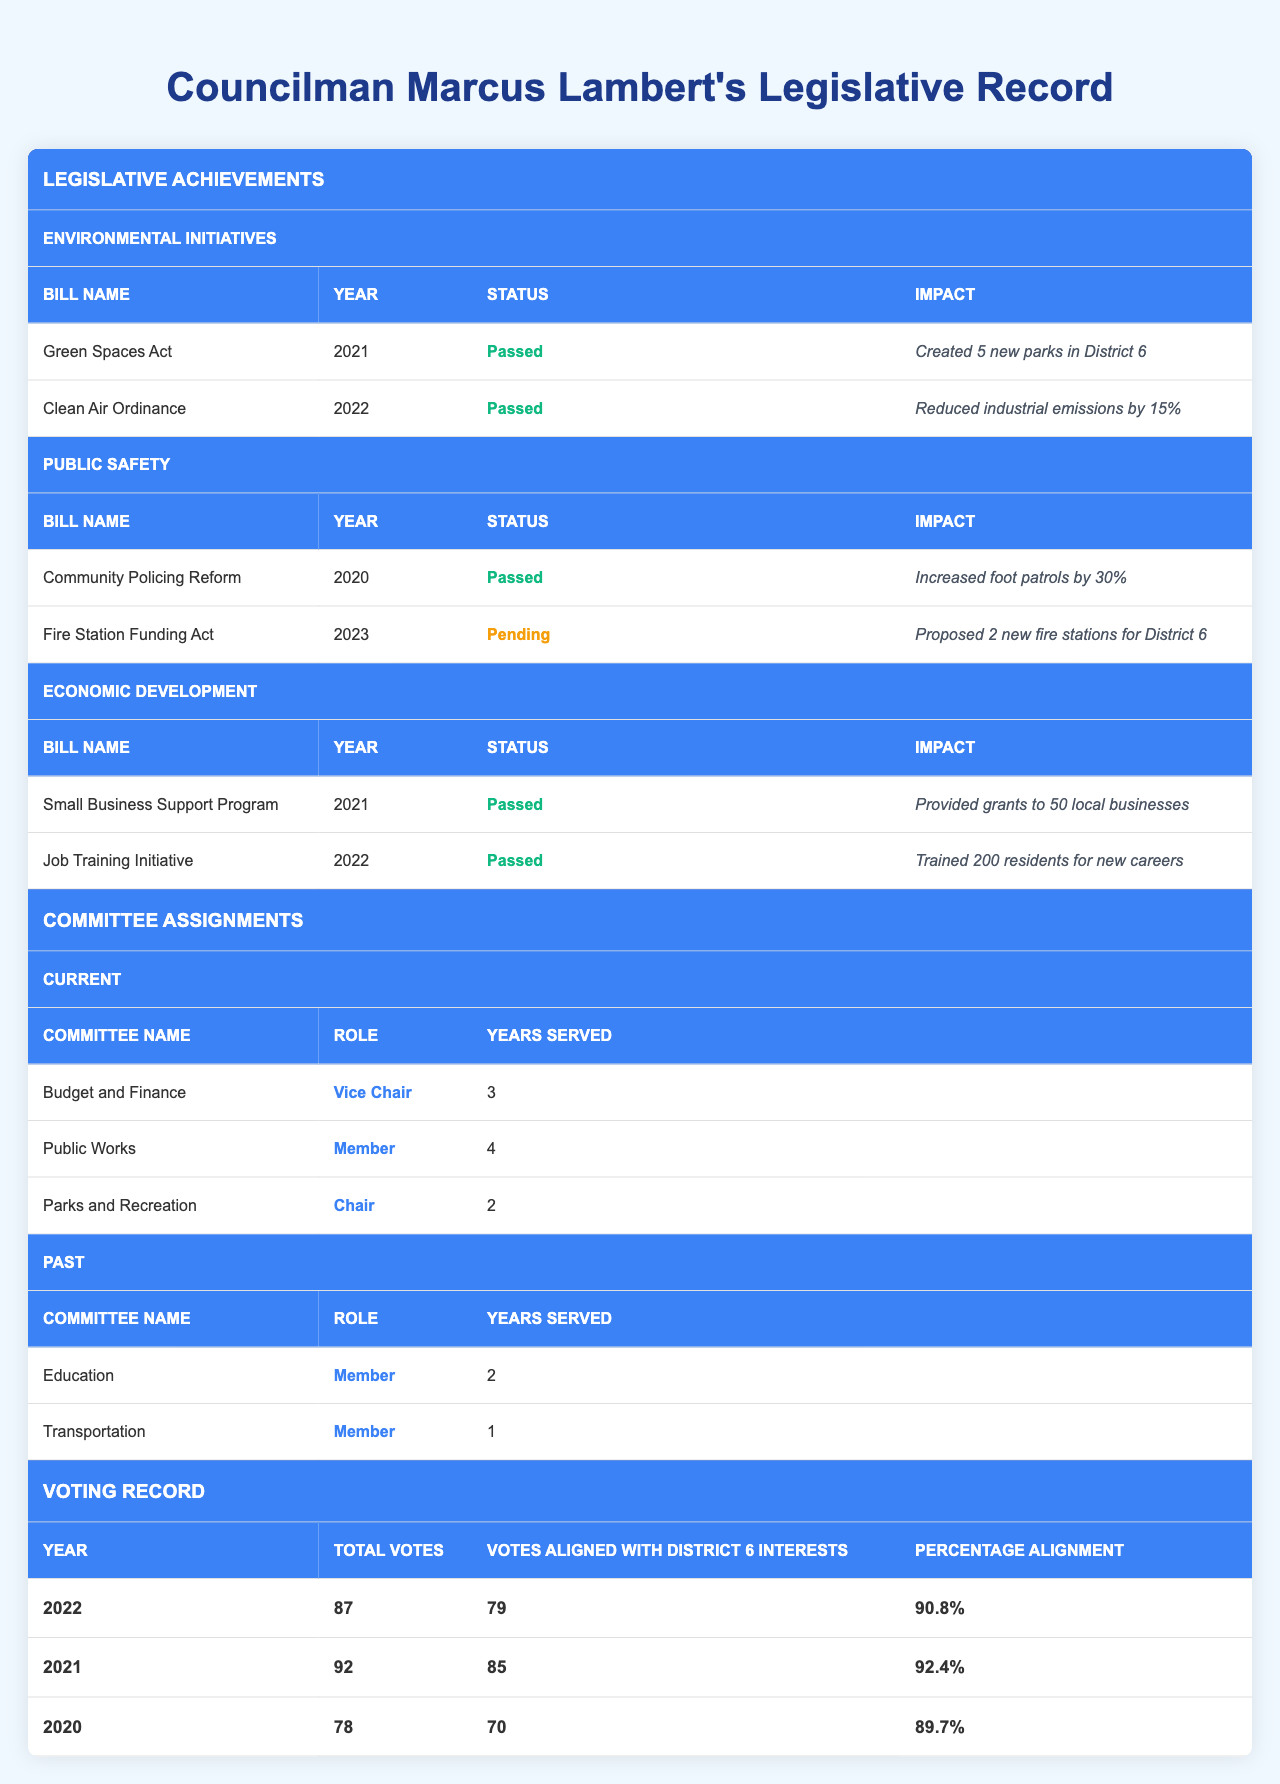What environmental initiative passed in 2021? The "Green Spaces Act" is listed under Environmental Initiatives with the year 2021 and the status "Passed".
Answer: Green Spaces Act How many years has Councilman Lambert served in the Public Works committee? The "Public Works" committee shows that Councilman Lambert has served for 4 years, as indicated in the Current Committee Assignments.
Answer: 4 years What was the impact of the "Clean Air Ordinance"? The impact statement for the "Clean Air Ordinance" specifies that it "Reduced industrial emissions by 15%", as shown in the Environmental Initiatives section.
Answer: Reduced industrial emissions by 15% Did Councilman Lambert's voting alignment exceed 90% in 2022? The percentage alignment for 2022 is noted as "90.8%", which is indeed above 90%.
Answer: Yes How many total votes did Councilman Lambert have in 2021? The table indicates the total votes for 2021 as 92, found in the Voting Record section.
Answer: 92 Which committee role has Councilman Lambert held the longest? By comparing the years served, "Public Works" (4 years) has the longest tenure, as it is shown in the Current Committee Assignments.
Answer: Public Works What percentage of Councilman Lambert's votes aligned with District 6 interests in 2020? The record shows that in 2020, the percentage alignment was "89.7%", found in the Voting Record section.
Answer: 89.7% In what year was the "Fire Station Funding Act" proposed, and what is its status? The "Fire Station Funding Act" is listed under Public Safety initiatives for the year 2023 and its status is "Pending".
Answer: Proposed in 2023, pending status What was the total number of votes Councilman Lambert cast across all three years listed? The total votes from each year are 78 (2020) + 92 (2021) + 87 (2022) = 257.
Answer: 257 How many local businesses received support from the Small Business Support Program? The impact of the "Small Business Support Program" indicates that it provided grants to "50 local businesses", as noted in the Economic Development initiatives.
Answer: 50 local businesses 